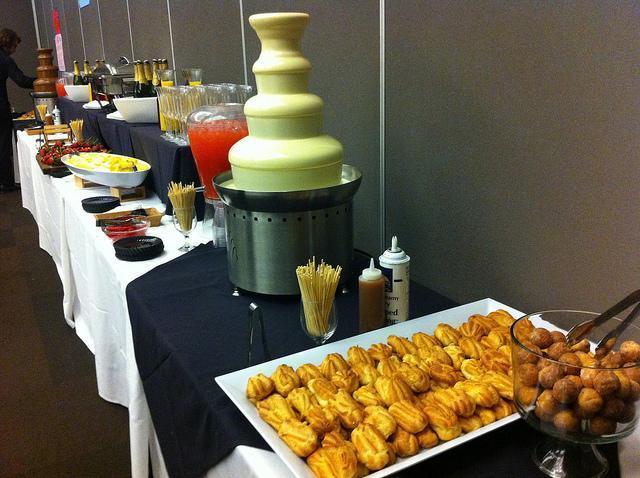How many bowls can you see?
Give a very brief answer. 2. How many people are sitting at the table?
Give a very brief answer. 0. 